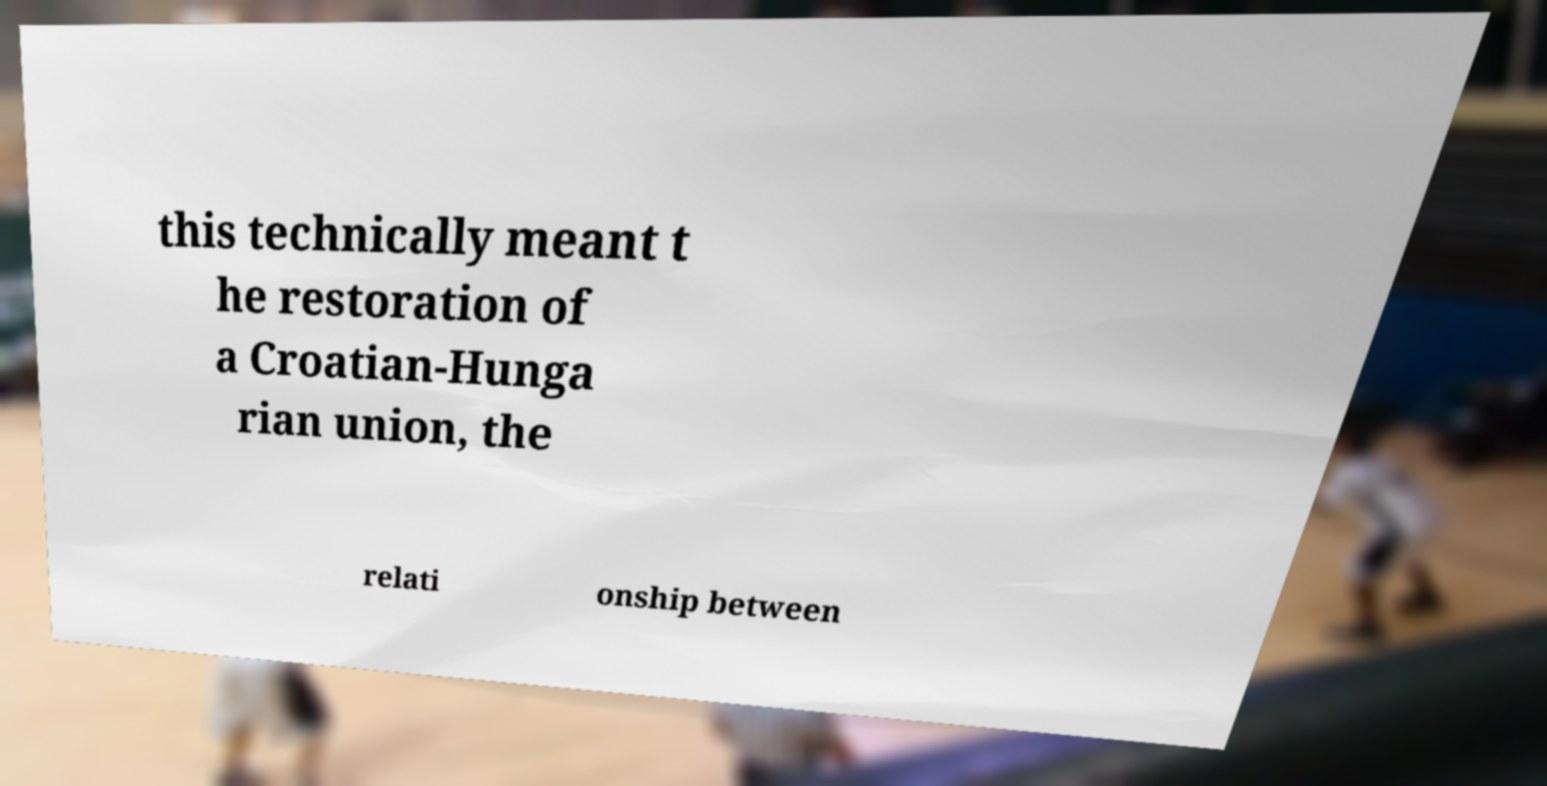What messages or text are displayed in this image? I need them in a readable, typed format. this technically meant t he restoration of a Croatian-Hunga rian union, the relati onship between 